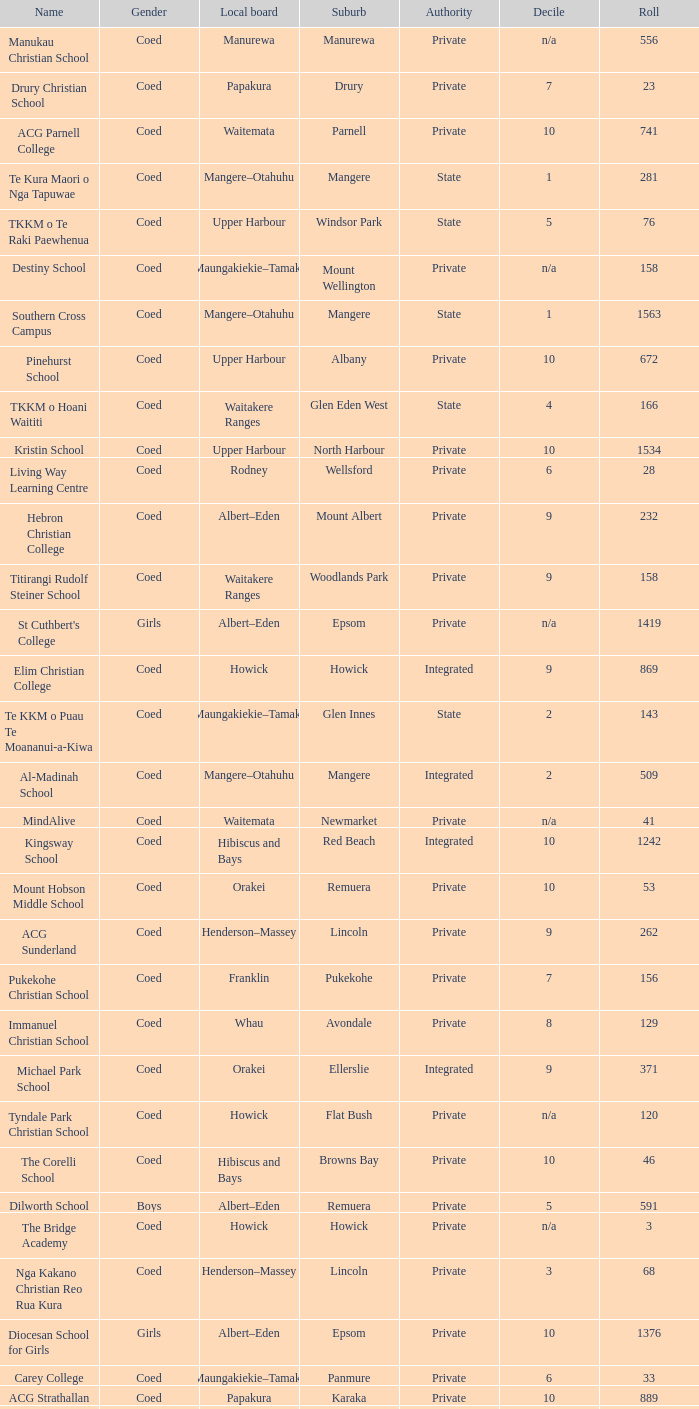Would you be able to parse every entry in this table? {'header': ['Name', 'Gender', 'Local board', 'Suburb', 'Authority', 'Decile', 'Roll'], 'rows': [['Manukau Christian School', 'Coed', 'Manurewa', 'Manurewa', 'Private', 'n/a', '556'], ['Drury Christian School', 'Coed', 'Papakura', 'Drury', 'Private', '7', '23'], ['ACG Parnell College', 'Coed', 'Waitemata', 'Parnell', 'Private', '10', '741'], ['Te Kura Maori o Nga Tapuwae', 'Coed', 'Mangere–Otahuhu', 'Mangere', 'State', '1', '281'], ['TKKM o Te Raki Paewhenua', 'Coed', 'Upper Harbour', 'Windsor Park', 'State', '5', '76'], ['Destiny School', 'Coed', 'Maungakiekie–Tamaki', 'Mount Wellington', 'Private', 'n/a', '158'], ['Southern Cross Campus', 'Coed', 'Mangere–Otahuhu', 'Mangere', 'State', '1', '1563'], ['Pinehurst School', 'Coed', 'Upper Harbour', 'Albany', 'Private', '10', '672'], ['TKKM o Hoani Waititi', 'Coed', 'Waitakere Ranges', 'Glen Eden West', 'State', '4', '166'], ['Kristin School', 'Coed', 'Upper Harbour', 'North Harbour', 'Private', '10', '1534'], ['Living Way Learning Centre', 'Coed', 'Rodney', 'Wellsford', 'Private', '6', '28'], ['Hebron Christian College', 'Coed', 'Albert–Eden', 'Mount Albert', 'Private', '9', '232'], ['Titirangi Rudolf Steiner School', 'Coed', 'Waitakere Ranges', 'Woodlands Park', 'Private', '9', '158'], ["St Cuthbert's College", 'Girls', 'Albert–Eden', 'Epsom', 'Private', 'n/a', '1419'], ['Elim Christian College', 'Coed', 'Howick', 'Howick', 'Integrated', '9', '869'], ['Te KKM o Puau Te Moananui-a-Kiwa', 'Coed', 'Maungakiekie–Tamaki', 'Glen Innes', 'State', '2', '143'], ['Al-Madinah School', 'Coed', 'Mangere–Otahuhu', 'Mangere', 'Integrated', '2', '509'], ['MindAlive', 'Coed', 'Waitemata', 'Newmarket', 'Private', 'n/a', '41'], ['Kingsway School', 'Coed', 'Hibiscus and Bays', 'Red Beach', 'Integrated', '10', '1242'], ['Mount Hobson Middle School', 'Coed', 'Orakei', 'Remuera', 'Private', '10', '53'], ['ACG Sunderland', 'Coed', 'Henderson–Massey', 'Lincoln', 'Private', '9', '262'], ['Pukekohe Christian School', 'Coed', 'Franklin', 'Pukekohe', 'Private', '7', '156'], ['Immanuel Christian School', 'Coed', 'Whau', 'Avondale', 'Private', '8', '129'], ['Michael Park School', 'Coed', 'Orakei', 'Ellerslie', 'Integrated', '9', '371'], ['Tyndale Park Christian School', 'Coed', 'Howick', 'Flat Bush', 'Private', 'n/a', '120'], ['The Corelli School', 'Coed', 'Hibiscus and Bays', 'Browns Bay', 'Private', '10', '46'], ['Dilworth School', 'Boys', 'Albert–Eden', 'Remuera', 'Private', '5', '591'], ['The Bridge Academy', 'Coed', 'Howick', 'Howick', 'Private', 'n/a', '3'], ['Nga Kakano Christian Reo Rua Kura', 'Coed', 'Henderson–Massey', 'Lincoln', 'Private', '3', '68'], ['Diocesan School for Girls', 'Girls', 'Albert–Eden', 'Epsom', 'Private', '10', '1376'], ['Carey College', 'Coed', 'Maungakiekie–Tamaki', 'Panmure', 'Private', '6', '33'], ['ACG Strathallan', 'Coed', 'Papakura', 'Karaka', 'Private', '10', '889'], ['TKKM o Mangere', 'Coed', 'Mangere–Otahuhu', 'Mangere', 'State', '2', '193']]} What gender has a local board of albert–eden with a roll of more than 232 and Decile of 5? Boys. 